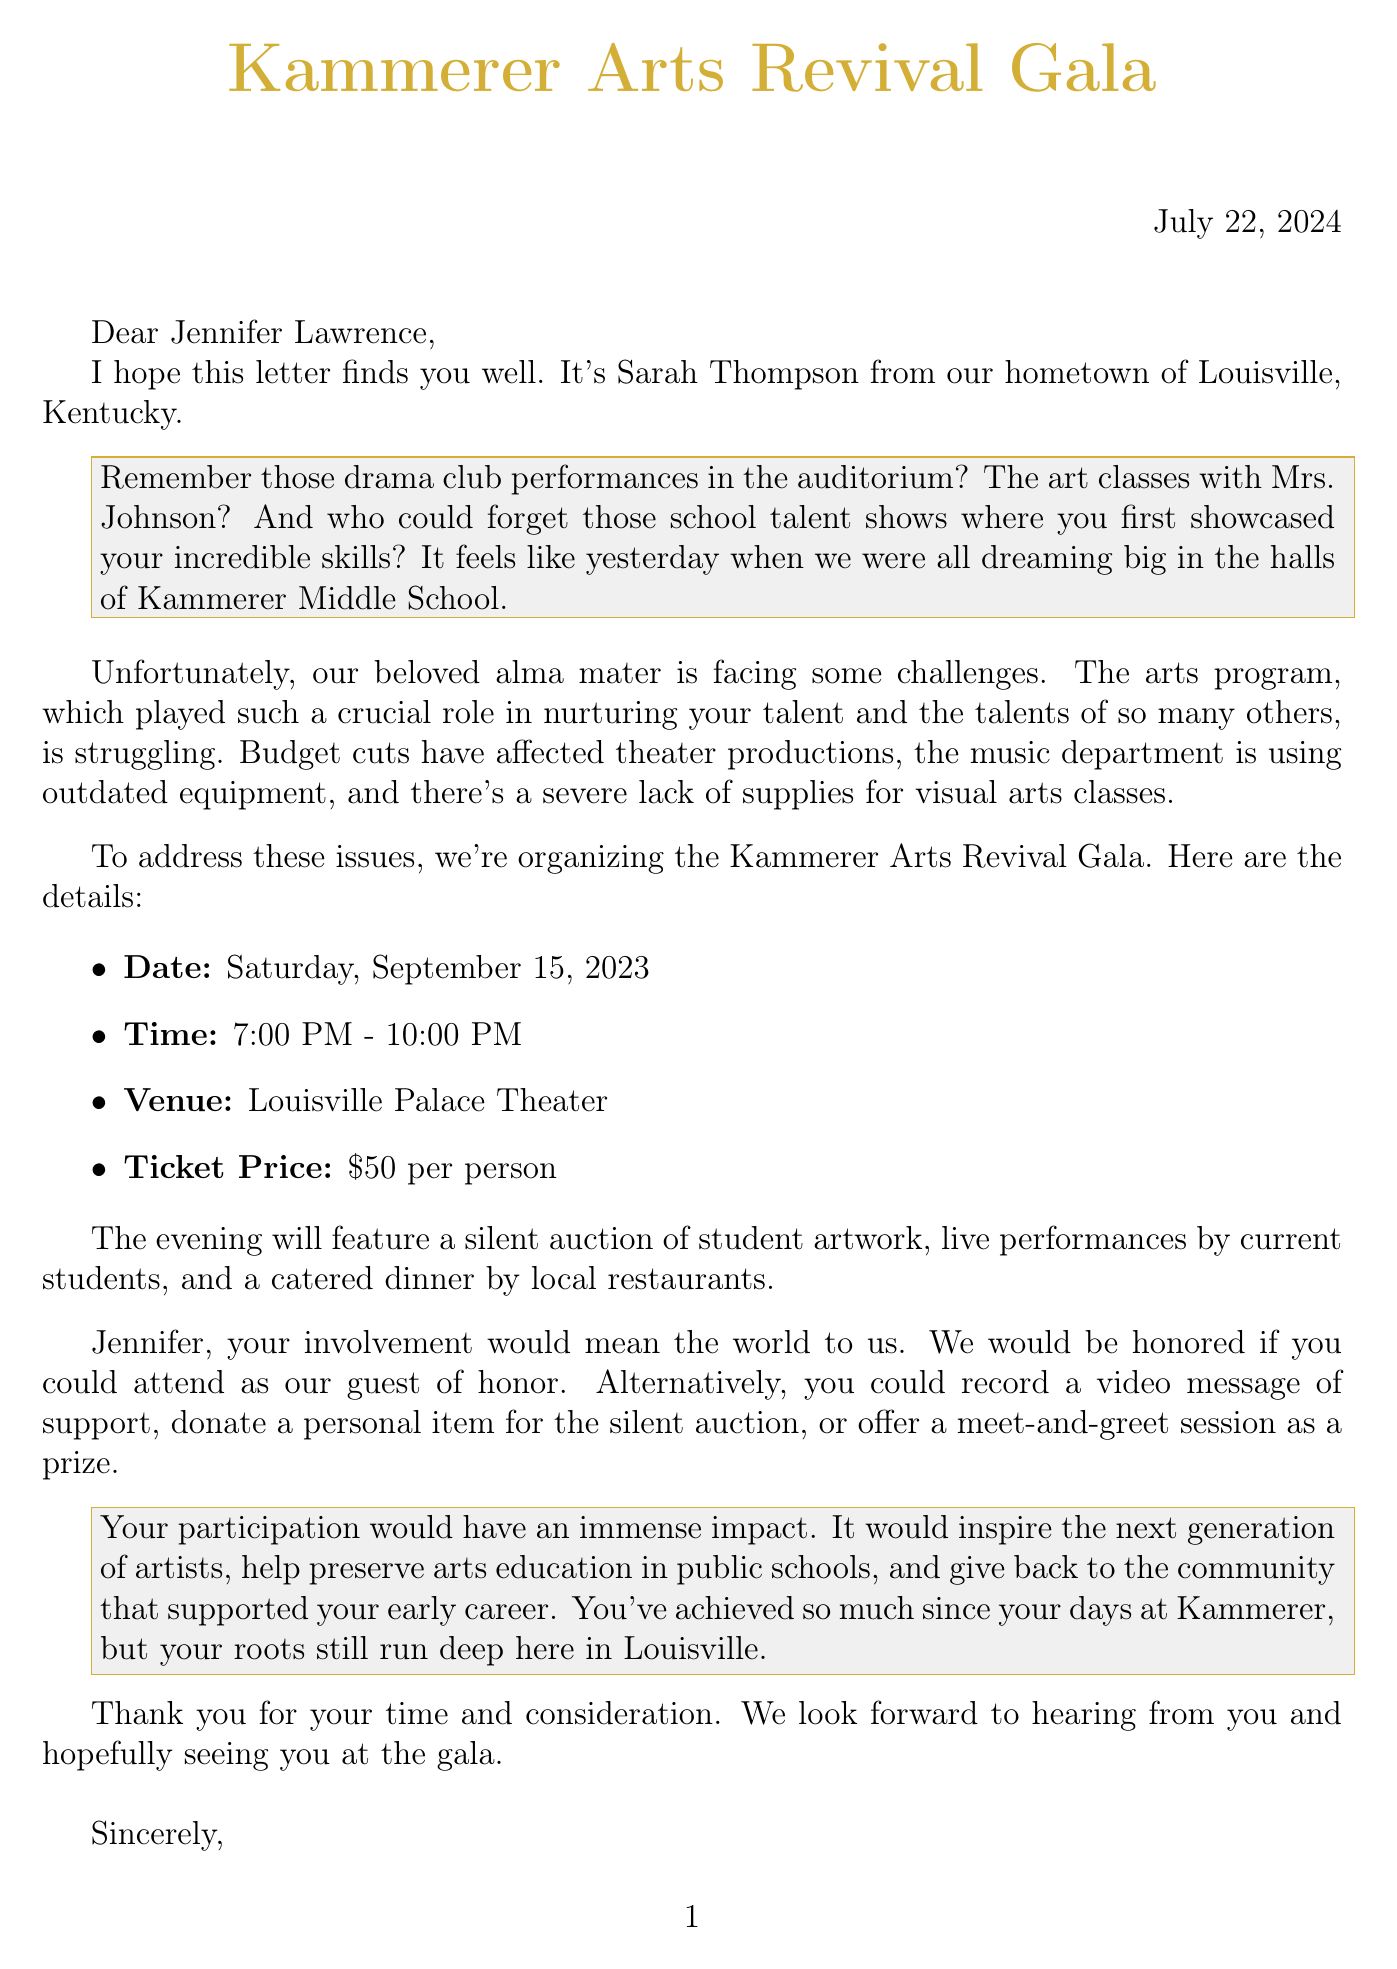What is the date of the Kammerer Arts Revival Gala? The date is explicitly mentioned in the document.
Answer: Saturday, September 15, 2023 Who is the current principal of Kammerer Middle School? The document names the current principal in the context of the letter.
Answer: Dr. Sarah Thompson What is the ticket price for the fundraiser? The ticket price is stated directly in the event details of the letter.
Answer: $50 per person What type of performances will take place during the event? The types of performances are listed in the fundraiser event details.
Answer: Live performances by current students What is one way the celebrity can participate in the fundraiser? Multiple options for involvement are provided in the document.
Answer: Attend as guest of honor What notable alumni are mentioned in the document? The document explicitly lists notable alumni associated with Kammerer Middle School.
Answer: Jennifer Lawrence, Muhammad Ali, Diane Sawyer Why is the arts program struggling? The document mentions specific challenges in the arts program related to budget cuts.
Answer: Budget cuts affecting theater productions What impact could the celebrity's participation have? The document outlines potential impacts of the celebrity's involvement on the community.
Answer: Inspiring the next generation of artists 